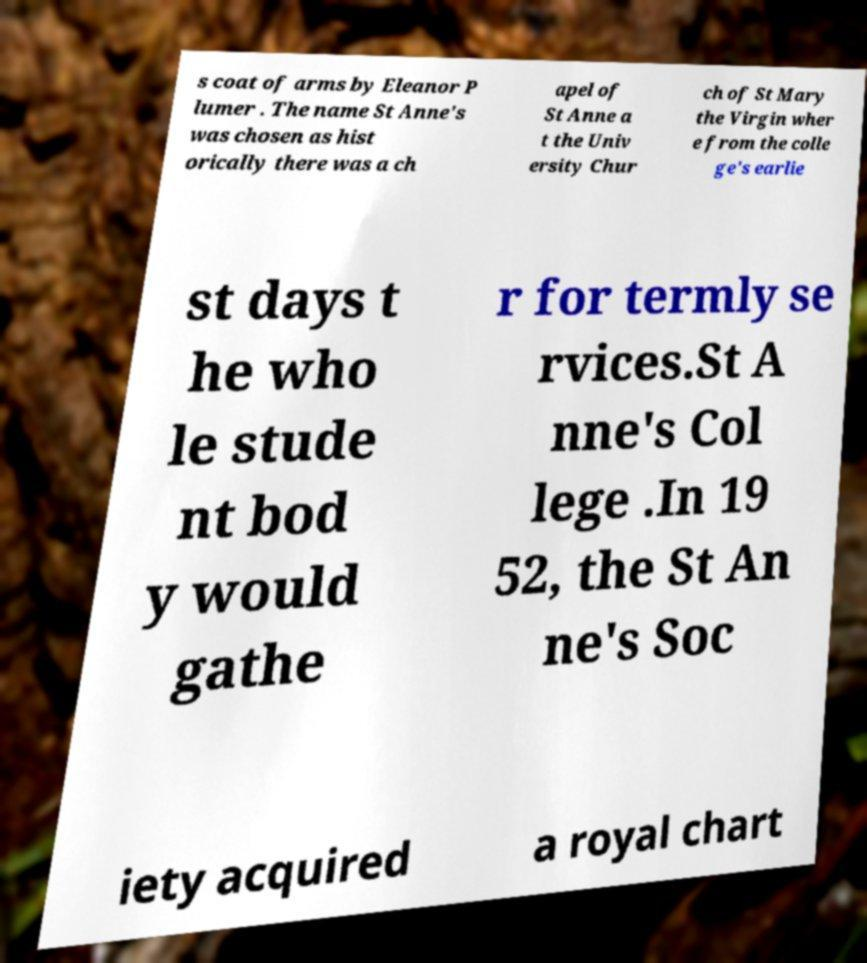I need the written content from this picture converted into text. Can you do that? s coat of arms by Eleanor P lumer . The name St Anne's was chosen as hist orically there was a ch apel of St Anne a t the Univ ersity Chur ch of St Mary the Virgin wher e from the colle ge's earlie st days t he who le stude nt bod y would gathe r for termly se rvices.St A nne's Col lege .In 19 52, the St An ne's Soc iety acquired a royal chart 